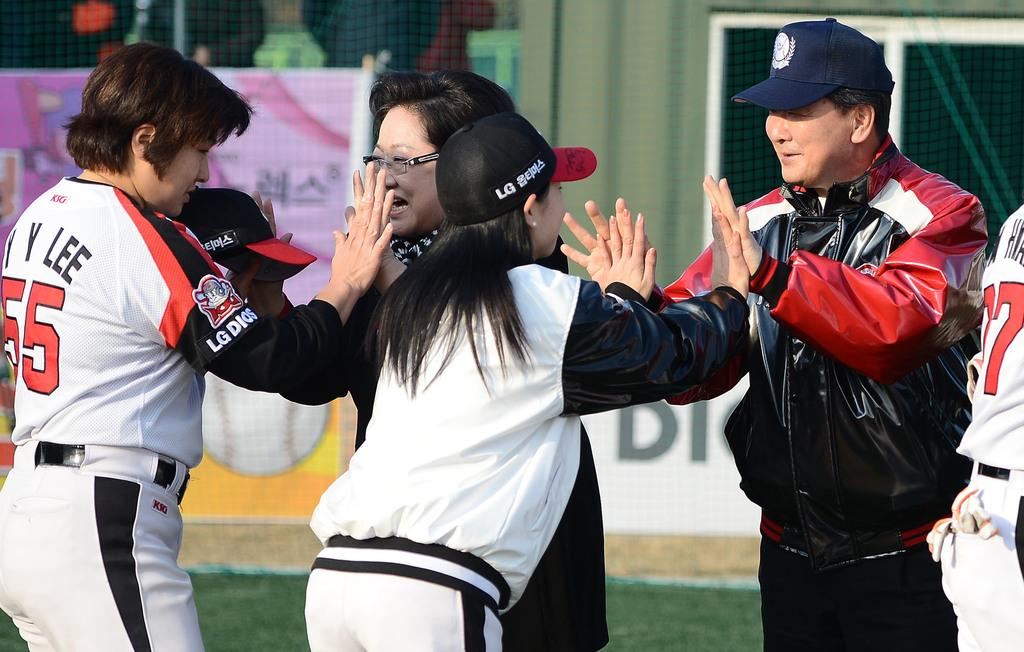<image>
Provide a brief description of the given image. A Baseball team giving each other high fives, their shirts display LG DIOS. 